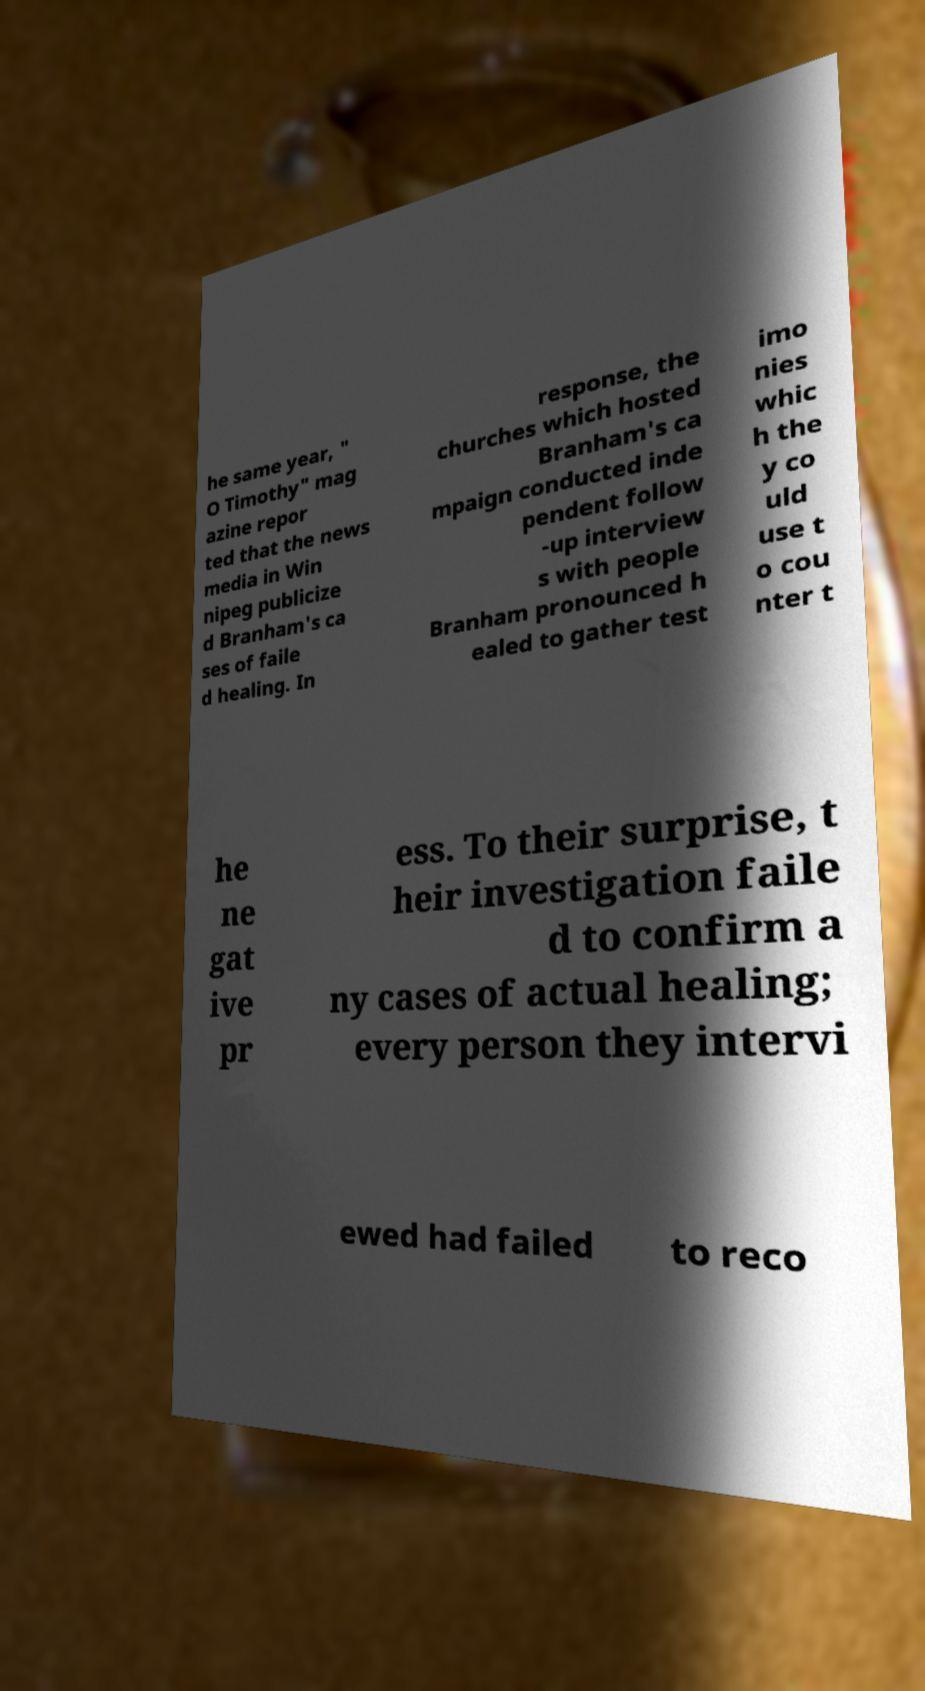Could you assist in decoding the text presented in this image and type it out clearly? he same year, " O Timothy" mag azine repor ted that the news media in Win nipeg publicize d Branham's ca ses of faile d healing. In response, the churches which hosted Branham's ca mpaign conducted inde pendent follow -up interview s with people Branham pronounced h ealed to gather test imo nies whic h the y co uld use t o cou nter t he ne gat ive pr ess. To their surprise, t heir investigation faile d to confirm a ny cases of actual healing; every person they intervi ewed had failed to reco 